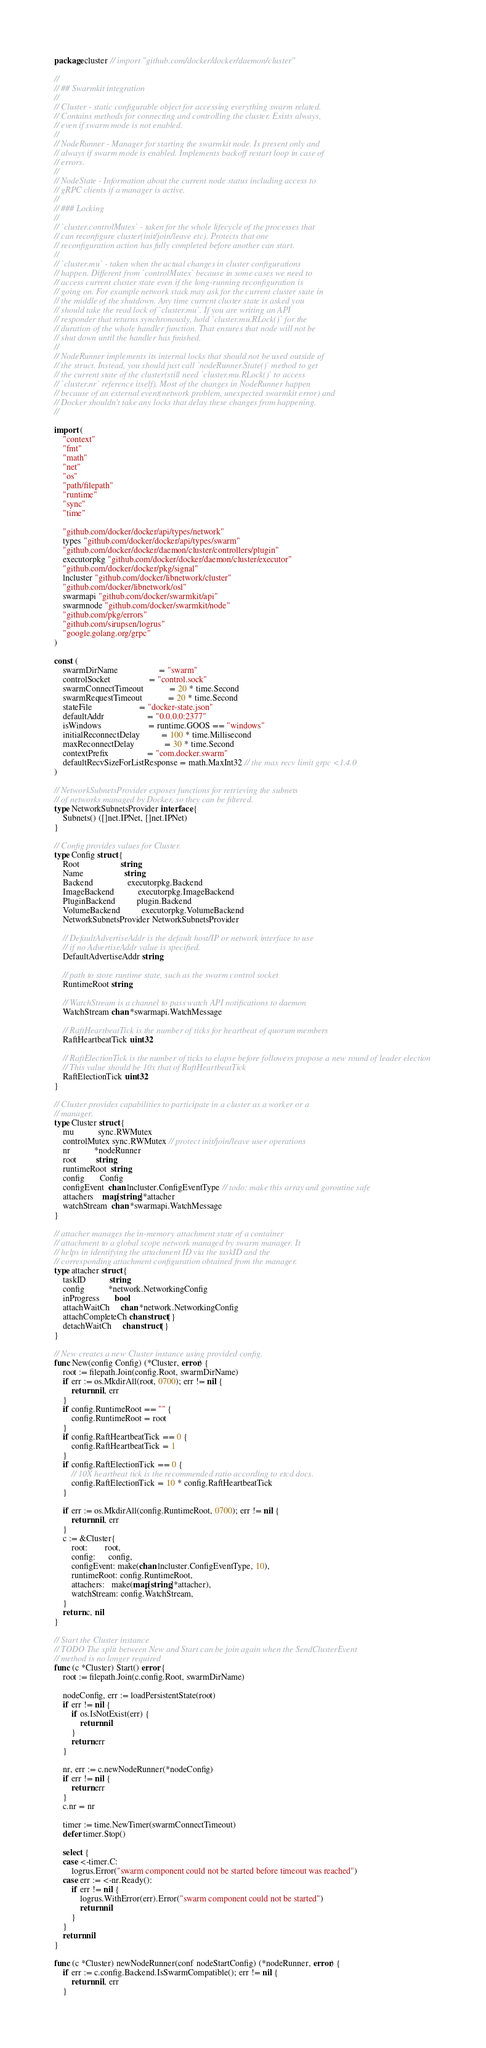Convert code to text. <code><loc_0><loc_0><loc_500><loc_500><_Go_>package cluster // import "github.com/docker/docker/daemon/cluster"

//
// ## Swarmkit integration
//
// Cluster - static configurable object for accessing everything swarm related.
// Contains methods for connecting and controlling the cluster. Exists always,
// even if swarm mode is not enabled.
//
// NodeRunner - Manager for starting the swarmkit node. Is present only and
// always if swarm mode is enabled. Implements backoff restart loop in case of
// errors.
//
// NodeState - Information about the current node status including access to
// gRPC clients if a manager is active.
//
// ### Locking
//
// `cluster.controlMutex` - taken for the whole lifecycle of the processes that
// can reconfigure cluster(init/join/leave etc). Protects that one
// reconfiguration action has fully completed before another can start.
//
// `cluster.mu` - taken when the actual changes in cluster configurations
// happen. Different from `controlMutex` because in some cases we need to
// access current cluster state even if the long-running reconfiguration is
// going on. For example network stack may ask for the current cluster state in
// the middle of the shutdown. Any time current cluster state is asked you
// should take the read lock of `cluster.mu`. If you are writing an API
// responder that returns synchronously, hold `cluster.mu.RLock()` for the
// duration of the whole handler function. That ensures that node will not be
// shut down until the handler has finished.
//
// NodeRunner implements its internal locks that should not be used outside of
// the struct. Instead, you should just call `nodeRunner.State()` method to get
// the current state of the cluster(still need `cluster.mu.RLock()` to access
// `cluster.nr` reference itself). Most of the changes in NodeRunner happen
// because of an external event(network problem, unexpected swarmkit error) and
// Docker shouldn't take any locks that delay these changes from happening.
//

import (
	"context"
	"fmt"
	"math"
	"net"
	"os"
	"path/filepath"
	"runtime"
	"sync"
	"time"

	"github.com/docker/docker/api/types/network"
	types "github.com/docker/docker/api/types/swarm"
	"github.com/docker/docker/daemon/cluster/controllers/plugin"
	executorpkg "github.com/docker/docker/daemon/cluster/executor"
	"github.com/docker/docker/pkg/signal"
	lncluster "github.com/docker/libnetwork/cluster"
	"github.com/docker/libnetwork/osl"
	swarmapi "github.com/docker/swarmkit/api"
	swarmnode "github.com/docker/swarmkit/node"
	"github.com/pkg/errors"
	"github.com/sirupsen/logrus"
	"google.golang.org/grpc"
)

const (
	swarmDirName                   = "swarm"
	controlSocket                  = "control.sock"
	swarmConnectTimeout            = 20 * time.Second
	swarmRequestTimeout            = 20 * time.Second
	stateFile                      = "docker-state.json"
	defaultAddr                    = "0.0.0.0:2377"
	isWindows                      = runtime.GOOS == "windows"
	initialReconnectDelay          = 100 * time.Millisecond
	maxReconnectDelay              = 30 * time.Second
	contextPrefix                  = "com.docker.swarm"
	defaultRecvSizeForListResponse = math.MaxInt32 // the max recv limit grpc <1.4.0
)

// NetworkSubnetsProvider exposes functions for retrieving the subnets
// of networks managed by Docker, so they can be filtered.
type NetworkSubnetsProvider interface {
	Subnets() ([]net.IPNet, []net.IPNet)
}

// Config provides values for Cluster.
type Config struct {
	Root                   string
	Name                   string
	Backend                executorpkg.Backend
	ImageBackend           executorpkg.ImageBackend
	PluginBackend          plugin.Backend
	VolumeBackend          executorpkg.VolumeBackend
	NetworkSubnetsProvider NetworkSubnetsProvider

	// DefaultAdvertiseAddr is the default host/IP or network interface to use
	// if no AdvertiseAddr value is specified.
	DefaultAdvertiseAddr string

	// path to store runtime state, such as the swarm control socket
	RuntimeRoot string

	// WatchStream is a channel to pass watch API notifications to daemon
	WatchStream chan *swarmapi.WatchMessage

	// RaftHeartbeatTick is the number of ticks for heartbeat of quorum members
	RaftHeartbeatTick uint32

	// RaftElectionTick is the number of ticks to elapse before followers propose a new round of leader election
	// This value should be 10x that of RaftHeartbeatTick
	RaftElectionTick uint32
}

// Cluster provides capabilities to participate in a cluster as a worker or a
// manager.
type Cluster struct {
	mu           sync.RWMutex
	controlMutex sync.RWMutex // protect init/join/leave user operations
	nr           *nodeRunner
	root         string
	runtimeRoot  string
	config       Config
	configEvent  chan lncluster.ConfigEventType // todo: make this array and goroutine safe
	attachers    map[string]*attacher
	watchStream  chan *swarmapi.WatchMessage
}

// attacher manages the in-memory attachment state of a container
// attachment to a global scope network managed by swarm manager. It
// helps in identifying the attachment ID via the taskID and the
// corresponding attachment configuration obtained from the manager.
type attacher struct {
	taskID           string
	config           *network.NetworkingConfig
	inProgress       bool
	attachWaitCh     chan *network.NetworkingConfig
	attachCompleteCh chan struct{}
	detachWaitCh     chan struct{}
}

// New creates a new Cluster instance using provided config.
func New(config Config) (*Cluster, error) {
	root := filepath.Join(config.Root, swarmDirName)
	if err := os.MkdirAll(root, 0700); err != nil {
		return nil, err
	}
	if config.RuntimeRoot == "" {
		config.RuntimeRoot = root
	}
	if config.RaftHeartbeatTick == 0 {
		config.RaftHeartbeatTick = 1
	}
	if config.RaftElectionTick == 0 {
		// 10X heartbeat tick is the recommended ratio according to etcd docs.
		config.RaftElectionTick = 10 * config.RaftHeartbeatTick
	}

	if err := os.MkdirAll(config.RuntimeRoot, 0700); err != nil {
		return nil, err
	}
	c := &Cluster{
		root:        root,
		config:      config,
		configEvent: make(chan lncluster.ConfigEventType, 10),
		runtimeRoot: config.RuntimeRoot,
		attachers:   make(map[string]*attacher),
		watchStream: config.WatchStream,
	}
	return c, nil
}

// Start the Cluster instance
// TODO The split between New and Start can be join again when the SendClusterEvent
// method is no longer required
func (c *Cluster) Start() error {
	root := filepath.Join(c.config.Root, swarmDirName)

	nodeConfig, err := loadPersistentState(root)
	if err != nil {
		if os.IsNotExist(err) {
			return nil
		}
		return err
	}

	nr, err := c.newNodeRunner(*nodeConfig)
	if err != nil {
		return err
	}
	c.nr = nr

	timer := time.NewTimer(swarmConnectTimeout)
	defer timer.Stop()

	select {
	case <-timer.C:
		logrus.Error("swarm component could not be started before timeout was reached")
	case err := <-nr.Ready():
		if err != nil {
			logrus.WithError(err).Error("swarm component could not be started")
			return nil
		}
	}
	return nil
}

func (c *Cluster) newNodeRunner(conf nodeStartConfig) (*nodeRunner, error) {
	if err := c.config.Backend.IsSwarmCompatible(); err != nil {
		return nil, err
	}
</code> 